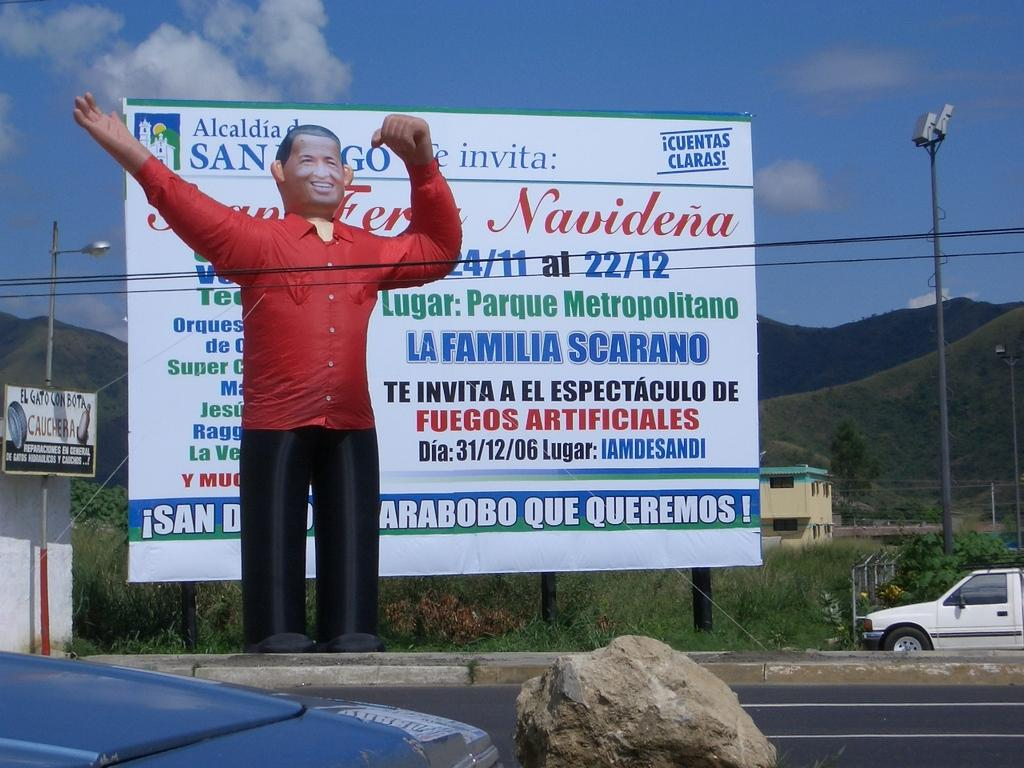<image>
Give a short and clear explanation of the subsequent image. the word Navidena is on a white sign outside in daytime 